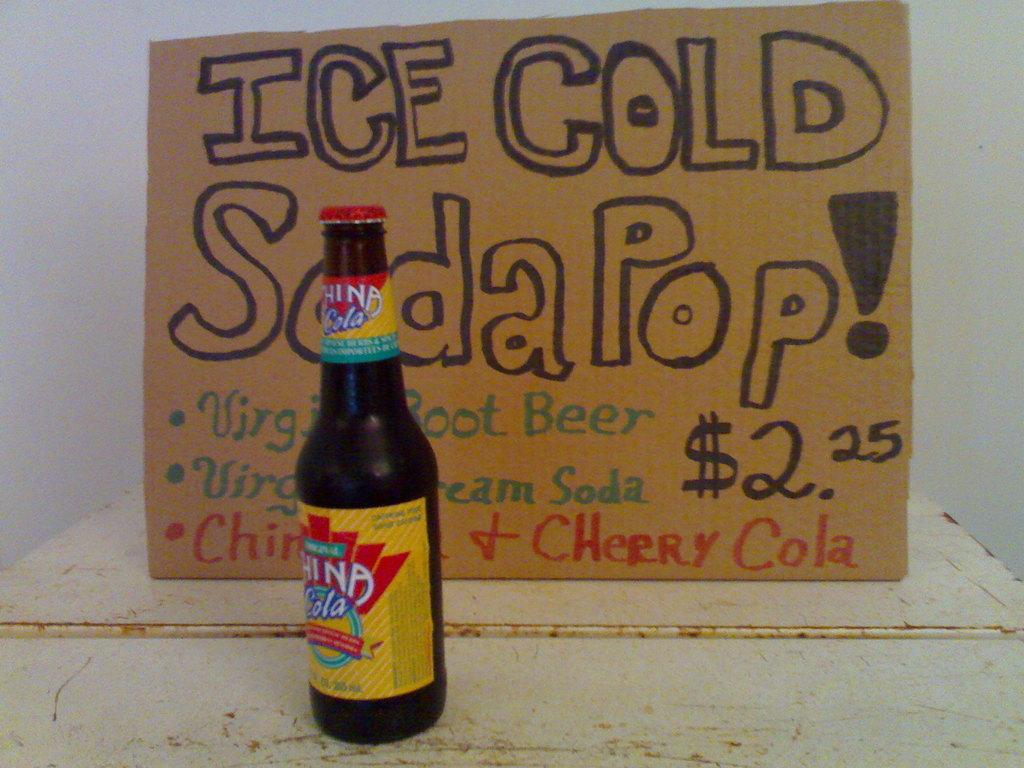<image>
Present a compact description of the photo's key features. A bottle of icee cold soda pop for $2.25 